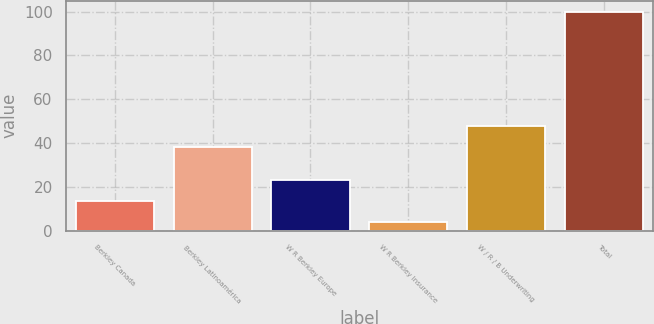Convert chart. <chart><loc_0><loc_0><loc_500><loc_500><bar_chart><fcel>Berkley Canada<fcel>Berkley Latinoamérica<fcel>W R Berkley Europe<fcel>W R Berkley Insurance<fcel>W / R / B Underwriting<fcel>Total<nl><fcel>13.69<fcel>38.3<fcel>23.28<fcel>4.1<fcel>47.89<fcel>100<nl></chart> 